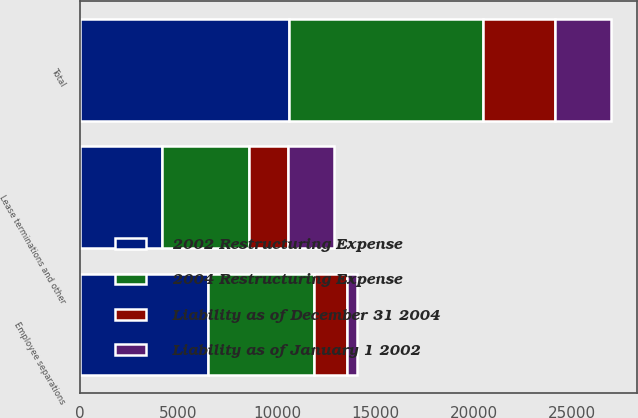Convert chart to OTSL. <chart><loc_0><loc_0><loc_500><loc_500><stacked_bar_chart><ecel><fcel>Employee separations<fcel>Lease terminations and other<fcel>Total<nl><fcel>Liability as of January 1 2002<fcel>537<fcel>2309<fcel>2846<nl><fcel>2002 Restructuring Expense<fcel>6501<fcel>4137<fcel>10638<nl><fcel>2004 Restructuring Expense<fcel>5399<fcel>4453<fcel>9852<nl><fcel>Liability as of December 31 2004<fcel>1639<fcel>1993<fcel>3632<nl></chart> 